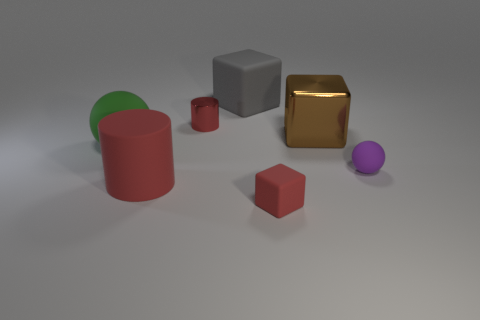Subtract all tiny matte cubes. How many cubes are left? 2 Subtract all red cubes. How many cubes are left? 2 Subtract 1 cubes. How many cubes are left? 2 Add 2 red rubber cubes. How many objects exist? 9 Subtract all blue cylinders. Subtract all purple spheres. How many cylinders are left? 2 Subtract all cylinders. How many objects are left? 5 Subtract all yellow cubes. How many blue cylinders are left? 0 Subtract all rubber spheres. Subtract all large brown metal objects. How many objects are left? 4 Add 1 red cylinders. How many red cylinders are left? 3 Add 2 balls. How many balls exist? 4 